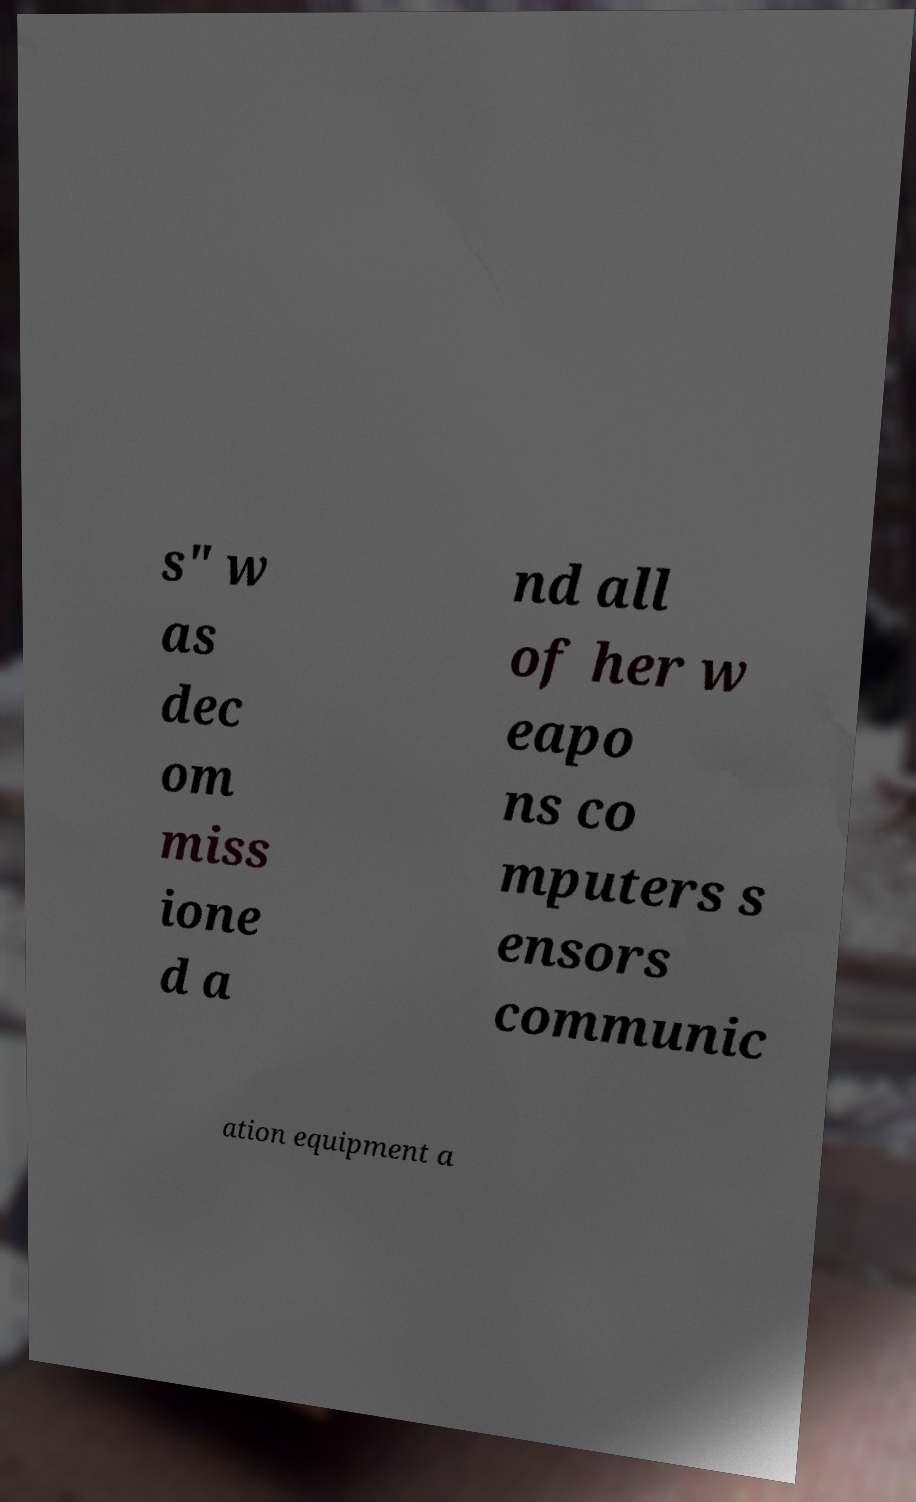What messages or text are displayed in this image? I need them in a readable, typed format. s" w as dec om miss ione d a nd all of her w eapo ns co mputers s ensors communic ation equipment a 